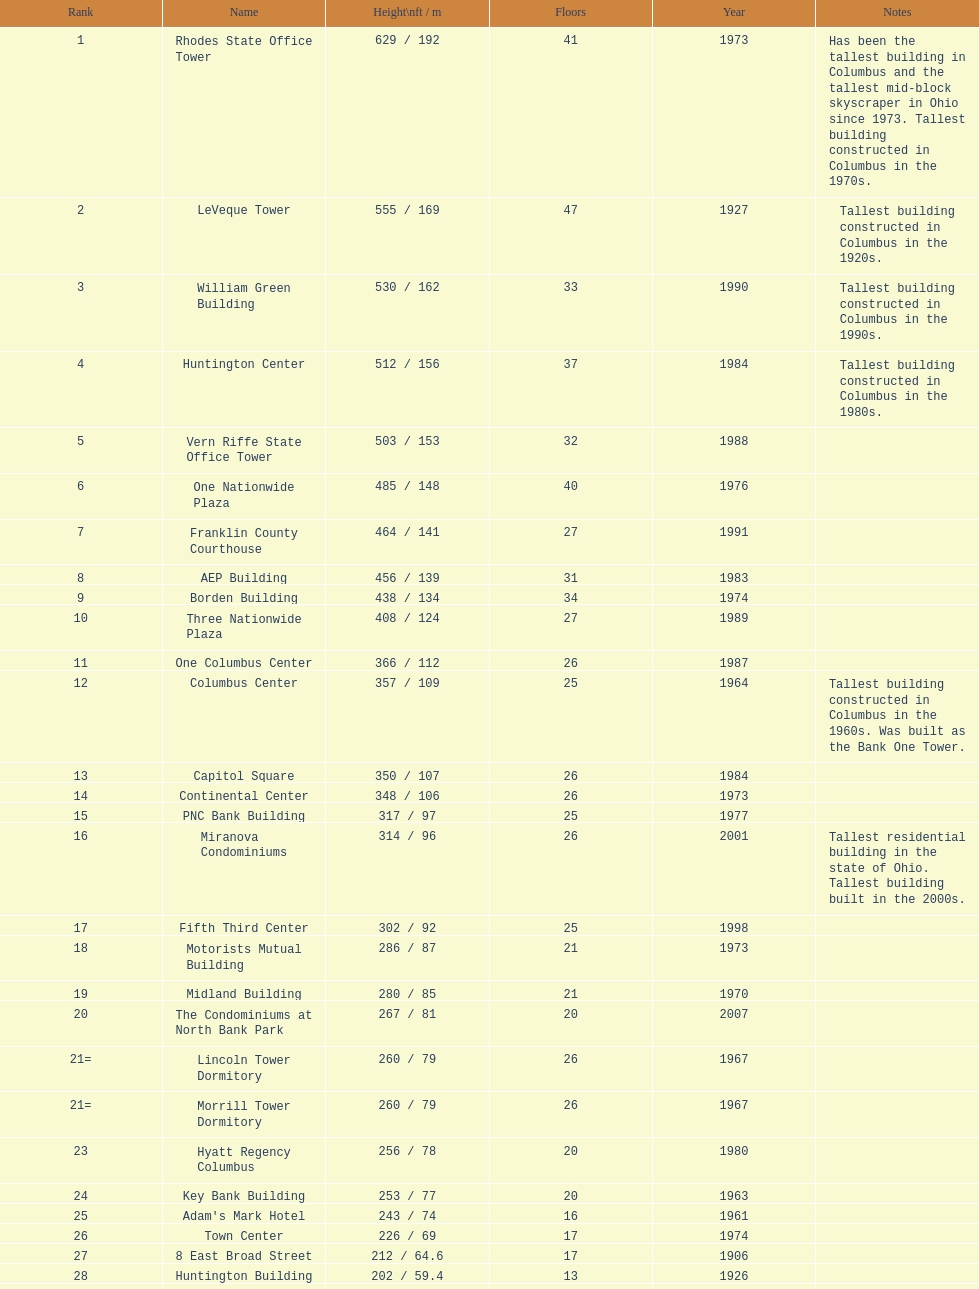Parse the table in full. {'header': ['Rank', 'Name', 'Height\\nft / m', 'Floors', 'Year', 'Notes'], 'rows': [['1', 'Rhodes State Office Tower', '629 / 192', '41', '1973', 'Has been the tallest building in Columbus and the tallest mid-block skyscraper in Ohio since 1973. Tallest building constructed in Columbus in the 1970s.'], ['2', 'LeVeque Tower', '555 / 169', '47', '1927', 'Tallest building constructed in Columbus in the 1920s.'], ['3', 'William Green Building', '530 / 162', '33', '1990', 'Tallest building constructed in Columbus in the 1990s.'], ['4', 'Huntington Center', '512 / 156', '37', '1984', 'Tallest building constructed in Columbus in the 1980s.'], ['5', 'Vern Riffe State Office Tower', '503 / 153', '32', '1988', ''], ['6', 'One Nationwide Plaza', '485 / 148', '40', '1976', ''], ['7', 'Franklin County Courthouse', '464 / 141', '27', '1991', ''], ['8', 'AEP Building', '456 / 139', '31', '1983', ''], ['9', 'Borden Building', '438 / 134', '34', '1974', ''], ['10', 'Three Nationwide Plaza', '408 / 124', '27', '1989', ''], ['11', 'One Columbus Center', '366 / 112', '26', '1987', ''], ['12', 'Columbus Center', '357 / 109', '25', '1964', 'Tallest building constructed in Columbus in the 1960s. Was built as the Bank One Tower.'], ['13', 'Capitol Square', '350 / 107', '26', '1984', ''], ['14', 'Continental Center', '348 / 106', '26', '1973', ''], ['15', 'PNC Bank Building', '317 / 97', '25', '1977', ''], ['16', 'Miranova Condominiums', '314 / 96', '26', '2001', 'Tallest residential building in the state of Ohio. Tallest building built in the 2000s.'], ['17', 'Fifth Third Center', '302 / 92', '25', '1998', ''], ['18', 'Motorists Mutual Building', '286 / 87', '21', '1973', ''], ['19', 'Midland Building', '280 / 85', '21', '1970', ''], ['20', 'The Condominiums at North Bank Park', '267 / 81', '20', '2007', ''], ['21=', 'Lincoln Tower Dormitory', '260 / 79', '26', '1967', ''], ['21=', 'Morrill Tower Dormitory', '260 / 79', '26', '1967', ''], ['23', 'Hyatt Regency Columbus', '256 / 78', '20', '1980', ''], ['24', 'Key Bank Building', '253 / 77', '20', '1963', ''], ['25', "Adam's Mark Hotel", '243 / 74', '16', '1961', ''], ['26', 'Town Center', '226 / 69', '17', '1974', ''], ['27', '8 East Broad Street', '212 / 64.6', '17', '1906', ''], ['28', 'Huntington Building', '202 / 59.4', '13', '1926', ''], ['29', 'Ohio Judicial Center', '200 / 57.9', '14', '1933', ''], ['30', '16 East Broad Street', '180 / 64.4', '13', '1900', '']]} What is the tallest building in columbus? Rhodes State Office Tower. 